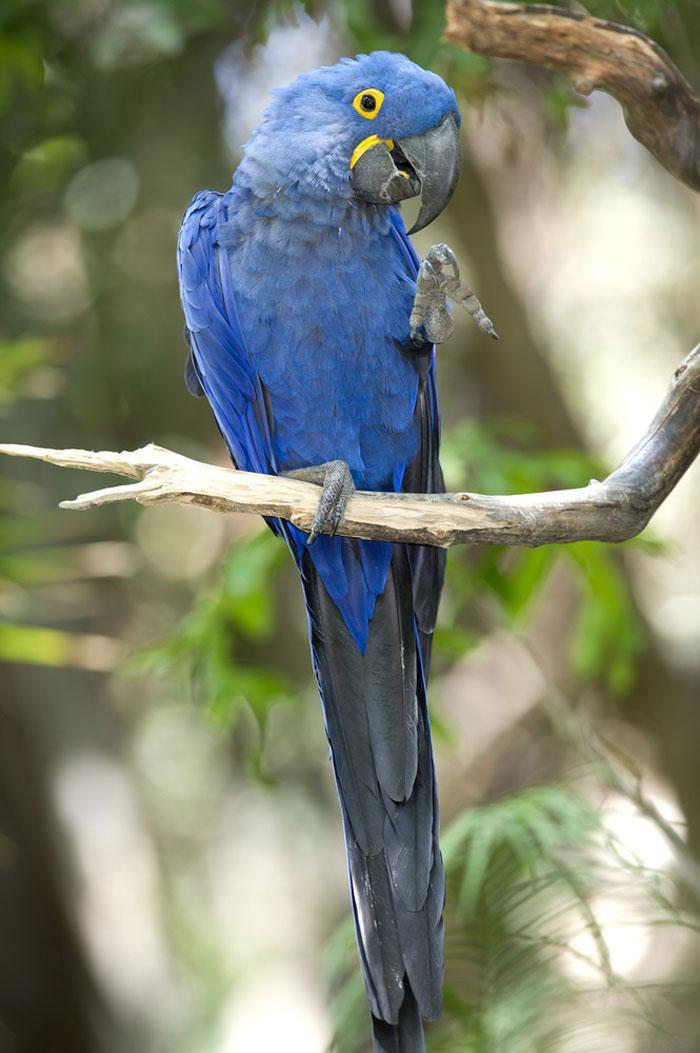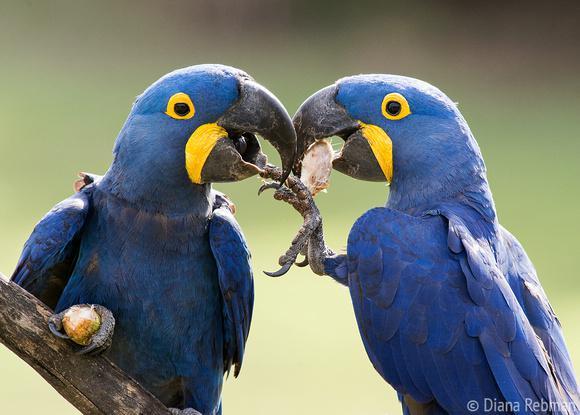The first image is the image on the left, the second image is the image on the right. For the images shown, is this caption "There are exactly two birds in total." true? Answer yes or no. No. The first image is the image on the left, the second image is the image on the right. Assess this claim about the two images: "There are two parrots.". Correct or not? Answer yes or no. No. 